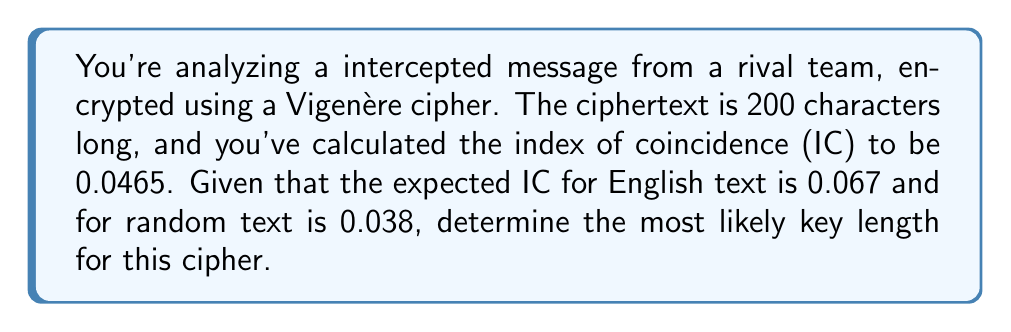Show me your answer to this math problem. Let's approach this step-by-step:

1) The formula for the relationship between the observed IC, the IC of the language, and the IC of random text is:

   $$IC_{observed} = \frac{1}{L} \cdot IC_{language} + \frac{L-1}{L} \cdot IC_{random}$$

   Where $L$ is the key length.

2) We know:
   $IC_{observed} = 0.0465$
   $IC_{language} = 0.067$ (for English)
   $IC_{random} = 0.038$

3) Let's substitute these values into our equation:

   $$0.0465 = \frac{1}{L} \cdot 0.067 + \frac{L-1}{L} \cdot 0.038$$

4) Simplify:
   $$0.0465 = \frac{0.067}{L} + 0.038 - \frac{0.038}{L}$$

5) Multiply both sides by $L$:
   $$0.0465L = 0.067 + 0.038L - 0.038$$

6) Simplify:
   $$0.0465L = 0.029 + 0.038L$$

7) Subtract $0.038L$ from both sides:
   $$0.0085L = 0.029$$

8) Divide both sides by 0.0085:
   $$L = \frac{0.029}{0.0085} \approx 3.41$$

9) Since the key length must be an integer, we round to the nearest whole number.
Answer: 3 